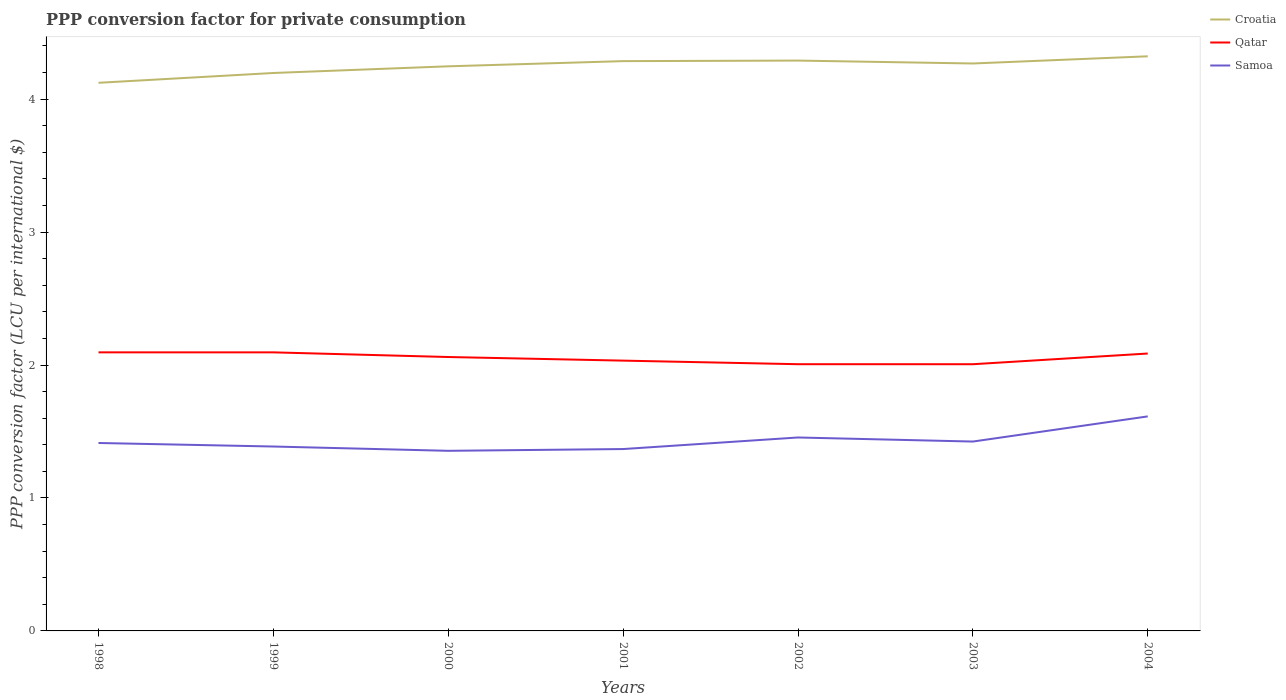Does the line corresponding to Qatar intersect with the line corresponding to Croatia?
Provide a short and direct response. No. Is the number of lines equal to the number of legend labels?
Ensure brevity in your answer.  Yes. Across all years, what is the maximum PPP conversion factor for private consumption in Qatar?
Make the answer very short. 2.01. What is the total PPP conversion factor for private consumption in Qatar in the graph?
Provide a short and direct response. 0.04. What is the difference between the highest and the second highest PPP conversion factor for private consumption in Croatia?
Offer a terse response. 0.2. What is the difference between the highest and the lowest PPP conversion factor for private consumption in Qatar?
Provide a succinct answer. 4. Are the values on the major ticks of Y-axis written in scientific E-notation?
Provide a short and direct response. No. Does the graph contain any zero values?
Make the answer very short. No. Does the graph contain grids?
Offer a very short reply. No. Where does the legend appear in the graph?
Make the answer very short. Top right. What is the title of the graph?
Offer a terse response. PPP conversion factor for private consumption. What is the label or title of the Y-axis?
Make the answer very short. PPP conversion factor (LCU per international $). What is the PPP conversion factor (LCU per international $) in Croatia in 1998?
Make the answer very short. 4.12. What is the PPP conversion factor (LCU per international $) of Qatar in 1998?
Make the answer very short. 2.1. What is the PPP conversion factor (LCU per international $) of Samoa in 1998?
Offer a terse response. 1.41. What is the PPP conversion factor (LCU per international $) in Croatia in 1999?
Make the answer very short. 4.2. What is the PPP conversion factor (LCU per international $) in Qatar in 1999?
Keep it short and to the point. 2.1. What is the PPP conversion factor (LCU per international $) in Samoa in 1999?
Make the answer very short. 1.39. What is the PPP conversion factor (LCU per international $) in Croatia in 2000?
Offer a terse response. 4.25. What is the PPP conversion factor (LCU per international $) in Qatar in 2000?
Ensure brevity in your answer.  2.06. What is the PPP conversion factor (LCU per international $) of Samoa in 2000?
Give a very brief answer. 1.35. What is the PPP conversion factor (LCU per international $) of Croatia in 2001?
Offer a very short reply. 4.29. What is the PPP conversion factor (LCU per international $) of Qatar in 2001?
Provide a short and direct response. 2.03. What is the PPP conversion factor (LCU per international $) of Samoa in 2001?
Make the answer very short. 1.37. What is the PPP conversion factor (LCU per international $) of Croatia in 2002?
Offer a terse response. 4.29. What is the PPP conversion factor (LCU per international $) in Qatar in 2002?
Offer a terse response. 2.01. What is the PPP conversion factor (LCU per international $) in Samoa in 2002?
Make the answer very short. 1.46. What is the PPP conversion factor (LCU per international $) of Croatia in 2003?
Provide a short and direct response. 4.27. What is the PPP conversion factor (LCU per international $) in Qatar in 2003?
Give a very brief answer. 2.01. What is the PPP conversion factor (LCU per international $) of Samoa in 2003?
Make the answer very short. 1.42. What is the PPP conversion factor (LCU per international $) in Croatia in 2004?
Your answer should be compact. 4.32. What is the PPP conversion factor (LCU per international $) of Qatar in 2004?
Provide a short and direct response. 2.09. What is the PPP conversion factor (LCU per international $) of Samoa in 2004?
Ensure brevity in your answer.  1.61. Across all years, what is the maximum PPP conversion factor (LCU per international $) in Croatia?
Offer a terse response. 4.32. Across all years, what is the maximum PPP conversion factor (LCU per international $) in Qatar?
Give a very brief answer. 2.1. Across all years, what is the maximum PPP conversion factor (LCU per international $) in Samoa?
Your answer should be compact. 1.61. Across all years, what is the minimum PPP conversion factor (LCU per international $) of Croatia?
Offer a terse response. 4.12. Across all years, what is the minimum PPP conversion factor (LCU per international $) of Qatar?
Your answer should be compact. 2.01. Across all years, what is the minimum PPP conversion factor (LCU per international $) of Samoa?
Offer a terse response. 1.35. What is the total PPP conversion factor (LCU per international $) of Croatia in the graph?
Your answer should be very brief. 29.73. What is the total PPP conversion factor (LCU per international $) of Qatar in the graph?
Offer a terse response. 14.38. What is the total PPP conversion factor (LCU per international $) of Samoa in the graph?
Make the answer very short. 10.02. What is the difference between the PPP conversion factor (LCU per international $) of Croatia in 1998 and that in 1999?
Keep it short and to the point. -0.07. What is the difference between the PPP conversion factor (LCU per international $) in Qatar in 1998 and that in 1999?
Make the answer very short. 0. What is the difference between the PPP conversion factor (LCU per international $) in Samoa in 1998 and that in 1999?
Your answer should be compact. 0.03. What is the difference between the PPP conversion factor (LCU per international $) in Croatia in 1998 and that in 2000?
Provide a short and direct response. -0.12. What is the difference between the PPP conversion factor (LCU per international $) in Qatar in 1998 and that in 2000?
Make the answer very short. 0.04. What is the difference between the PPP conversion factor (LCU per international $) in Samoa in 1998 and that in 2000?
Your response must be concise. 0.06. What is the difference between the PPP conversion factor (LCU per international $) of Croatia in 1998 and that in 2001?
Ensure brevity in your answer.  -0.16. What is the difference between the PPP conversion factor (LCU per international $) of Qatar in 1998 and that in 2001?
Your answer should be compact. 0.06. What is the difference between the PPP conversion factor (LCU per international $) in Samoa in 1998 and that in 2001?
Make the answer very short. 0.05. What is the difference between the PPP conversion factor (LCU per international $) of Croatia in 1998 and that in 2002?
Offer a very short reply. -0.17. What is the difference between the PPP conversion factor (LCU per international $) of Qatar in 1998 and that in 2002?
Keep it short and to the point. 0.09. What is the difference between the PPP conversion factor (LCU per international $) in Samoa in 1998 and that in 2002?
Offer a very short reply. -0.04. What is the difference between the PPP conversion factor (LCU per international $) in Croatia in 1998 and that in 2003?
Give a very brief answer. -0.15. What is the difference between the PPP conversion factor (LCU per international $) in Qatar in 1998 and that in 2003?
Ensure brevity in your answer.  0.09. What is the difference between the PPP conversion factor (LCU per international $) of Samoa in 1998 and that in 2003?
Keep it short and to the point. -0.01. What is the difference between the PPP conversion factor (LCU per international $) of Croatia in 1998 and that in 2004?
Your answer should be compact. -0.2. What is the difference between the PPP conversion factor (LCU per international $) of Qatar in 1998 and that in 2004?
Keep it short and to the point. 0.01. What is the difference between the PPP conversion factor (LCU per international $) in Samoa in 1998 and that in 2004?
Provide a succinct answer. -0.2. What is the difference between the PPP conversion factor (LCU per international $) of Croatia in 1999 and that in 2000?
Ensure brevity in your answer.  -0.05. What is the difference between the PPP conversion factor (LCU per international $) of Qatar in 1999 and that in 2000?
Your response must be concise. 0.04. What is the difference between the PPP conversion factor (LCU per international $) in Samoa in 1999 and that in 2000?
Make the answer very short. 0.03. What is the difference between the PPP conversion factor (LCU per international $) in Croatia in 1999 and that in 2001?
Your response must be concise. -0.09. What is the difference between the PPP conversion factor (LCU per international $) of Qatar in 1999 and that in 2001?
Provide a short and direct response. 0.06. What is the difference between the PPP conversion factor (LCU per international $) of Samoa in 1999 and that in 2001?
Offer a terse response. 0.02. What is the difference between the PPP conversion factor (LCU per international $) of Croatia in 1999 and that in 2002?
Make the answer very short. -0.09. What is the difference between the PPP conversion factor (LCU per international $) of Qatar in 1999 and that in 2002?
Ensure brevity in your answer.  0.09. What is the difference between the PPP conversion factor (LCU per international $) in Samoa in 1999 and that in 2002?
Offer a very short reply. -0.07. What is the difference between the PPP conversion factor (LCU per international $) of Croatia in 1999 and that in 2003?
Your response must be concise. -0.07. What is the difference between the PPP conversion factor (LCU per international $) in Qatar in 1999 and that in 2003?
Your answer should be compact. 0.09. What is the difference between the PPP conversion factor (LCU per international $) of Samoa in 1999 and that in 2003?
Ensure brevity in your answer.  -0.04. What is the difference between the PPP conversion factor (LCU per international $) in Croatia in 1999 and that in 2004?
Make the answer very short. -0.13. What is the difference between the PPP conversion factor (LCU per international $) in Qatar in 1999 and that in 2004?
Make the answer very short. 0.01. What is the difference between the PPP conversion factor (LCU per international $) in Samoa in 1999 and that in 2004?
Offer a very short reply. -0.23. What is the difference between the PPP conversion factor (LCU per international $) in Croatia in 2000 and that in 2001?
Make the answer very short. -0.04. What is the difference between the PPP conversion factor (LCU per international $) in Qatar in 2000 and that in 2001?
Your answer should be compact. 0.03. What is the difference between the PPP conversion factor (LCU per international $) in Samoa in 2000 and that in 2001?
Your answer should be compact. -0.01. What is the difference between the PPP conversion factor (LCU per international $) in Croatia in 2000 and that in 2002?
Provide a short and direct response. -0.04. What is the difference between the PPP conversion factor (LCU per international $) of Qatar in 2000 and that in 2002?
Offer a terse response. 0.05. What is the difference between the PPP conversion factor (LCU per international $) in Samoa in 2000 and that in 2002?
Give a very brief answer. -0.1. What is the difference between the PPP conversion factor (LCU per international $) in Croatia in 2000 and that in 2003?
Provide a short and direct response. -0.02. What is the difference between the PPP conversion factor (LCU per international $) of Qatar in 2000 and that in 2003?
Offer a terse response. 0.05. What is the difference between the PPP conversion factor (LCU per international $) in Samoa in 2000 and that in 2003?
Offer a terse response. -0.07. What is the difference between the PPP conversion factor (LCU per international $) of Croatia in 2000 and that in 2004?
Give a very brief answer. -0.08. What is the difference between the PPP conversion factor (LCU per international $) in Qatar in 2000 and that in 2004?
Offer a terse response. -0.03. What is the difference between the PPP conversion factor (LCU per international $) in Samoa in 2000 and that in 2004?
Give a very brief answer. -0.26. What is the difference between the PPP conversion factor (LCU per international $) of Croatia in 2001 and that in 2002?
Your response must be concise. -0. What is the difference between the PPP conversion factor (LCU per international $) of Qatar in 2001 and that in 2002?
Keep it short and to the point. 0.03. What is the difference between the PPP conversion factor (LCU per international $) of Samoa in 2001 and that in 2002?
Your response must be concise. -0.09. What is the difference between the PPP conversion factor (LCU per international $) in Croatia in 2001 and that in 2003?
Offer a terse response. 0.02. What is the difference between the PPP conversion factor (LCU per international $) of Qatar in 2001 and that in 2003?
Ensure brevity in your answer.  0.03. What is the difference between the PPP conversion factor (LCU per international $) in Samoa in 2001 and that in 2003?
Your response must be concise. -0.06. What is the difference between the PPP conversion factor (LCU per international $) in Croatia in 2001 and that in 2004?
Ensure brevity in your answer.  -0.04. What is the difference between the PPP conversion factor (LCU per international $) of Qatar in 2001 and that in 2004?
Keep it short and to the point. -0.05. What is the difference between the PPP conversion factor (LCU per international $) in Samoa in 2001 and that in 2004?
Your response must be concise. -0.25. What is the difference between the PPP conversion factor (LCU per international $) of Croatia in 2002 and that in 2003?
Make the answer very short. 0.02. What is the difference between the PPP conversion factor (LCU per international $) in Samoa in 2002 and that in 2003?
Offer a very short reply. 0.03. What is the difference between the PPP conversion factor (LCU per international $) in Croatia in 2002 and that in 2004?
Keep it short and to the point. -0.03. What is the difference between the PPP conversion factor (LCU per international $) of Qatar in 2002 and that in 2004?
Offer a very short reply. -0.08. What is the difference between the PPP conversion factor (LCU per international $) in Samoa in 2002 and that in 2004?
Ensure brevity in your answer.  -0.16. What is the difference between the PPP conversion factor (LCU per international $) in Croatia in 2003 and that in 2004?
Provide a succinct answer. -0.05. What is the difference between the PPP conversion factor (LCU per international $) in Qatar in 2003 and that in 2004?
Provide a short and direct response. -0.08. What is the difference between the PPP conversion factor (LCU per international $) of Samoa in 2003 and that in 2004?
Offer a terse response. -0.19. What is the difference between the PPP conversion factor (LCU per international $) of Croatia in 1998 and the PPP conversion factor (LCU per international $) of Qatar in 1999?
Your answer should be compact. 2.03. What is the difference between the PPP conversion factor (LCU per international $) of Croatia in 1998 and the PPP conversion factor (LCU per international $) of Samoa in 1999?
Offer a terse response. 2.74. What is the difference between the PPP conversion factor (LCU per international $) in Qatar in 1998 and the PPP conversion factor (LCU per international $) in Samoa in 1999?
Offer a terse response. 0.71. What is the difference between the PPP conversion factor (LCU per international $) in Croatia in 1998 and the PPP conversion factor (LCU per international $) in Qatar in 2000?
Offer a very short reply. 2.06. What is the difference between the PPP conversion factor (LCU per international $) of Croatia in 1998 and the PPP conversion factor (LCU per international $) of Samoa in 2000?
Your response must be concise. 2.77. What is the difference between the PPP conversion factor (LCU per international $) of Qatar in 1998 and the PPP conversion factor (LCU per international $) of Samoa in 2000?
Provide a short and direct response. 0.74. What is the difference between the PPP conversion factor (LCU per international $) of Croatia in 1998 and the PPP conversion factor (LCU per international $) of Qatar in 2001?
Provide a succinct answer. 2.09. What is the difference between the PPP conversion factor (LCU per international $) in Croatia in 1998 and the PPP conversion factor (LCU per international $) in Samoa in 2001?
Provide a succinct answer. 2.75. What is the difference between the PPP conversion factor (LCU per international $) in Qatar in 1998 and the PPP conversion factor (LCU per international $) in Samoa in 2001?
Your response must be concise. 0.73. What is the difference between the PPP conversion factor (LCU per international $) of Croatia in 1998 and the PPP conversion factor (LCU per international $) of Qatar in 2002?
Give a very brief answer. 2.12. What is the difference between the PPP conversion factor (LCU per international $) in Croatia in 1998 and the PPP conversion factor (LCU per international $) in Samoa in 2002?
Give a very brief answer. 2.67. What is the difference between the PPP conversion factor (LCU per international $) of Qatar in 1998 and the PPP conversion factor (LCU per international $) of Samoa in 2002?
Offer a terse response. 0.64. What is the difference between the PPP conversion factor (LCU per international $) of Croatia in 1998 and the PPP conversion factor (LCU per international $) of Qatar in 2003?
Make the answer very short. 2.12. What is the difference between the PPP conversion factor (LCU per international $) in Croatia in 1998 and the PPP conversion factor (LCU per international $) in Samoa in 2003?
Offer a very short reply. 2.7. What is the difference between the PPP conversion factor (LCU per international $) of Qatar in 1998 and the PPP conversion factor (LCU per international $) of Samoa in 2003?
Provide a succinct answer. 0.67. What is the difference between the PPP conversion factor (LCU per international $) in Croatia in 1998 and the PPP conversion factor (LCU per international $) in Qatar in 2004?
Your answer should be very brief. 2.04. What is the difference between the PPP conversion factor (LCU per international $) of Croatia in 1998 and the PPP conversion factor (LCU per international $) of Samoa in 2004?
Provide a short and direct response. 2.51. What is the difference between the PPP conversion factor (LCU per international $) of Qatar in 1998 and the PPP conversion factor (LCU per international $) of Samoa in 2004?
Your response must be concise. 0.48. What is the difference between the PPP conversion factor (LCU per international $) of Croatia in 1999 and the PPP conversion factor (LCU per international $) of Qatar in 2000?
Ensure brevity in your answer.  2.14. What is the difference between the PPP conversion factor (LCU per international $) of Croatia in 1999 and the PPP conversion factor (LCU per international $) of Samoa in 2000?
Provide a succinct answer. 2.84. What is the difference between the PPP conversion factor (LCU per international $) in Qatar in 1999 and the PPP conversion factor (LCU per international $) in Samoa in 2000?
Your answer should be very brief. 0.74. What is the difference between the PPP conversion factor (LCU per international $) in Croatia in 1999 and the PPP conversion factor (LCU per international $) in Qatar in 2001?
Your answer should be very brief. 2.16. What is the difference between the PPP conversion factor (LCU per international $) in Croatia in 1999 and the PPP conversion factor (LCU per international $) in Samoa in 2001?
Give a very brief answer. 2.83. What is the difference between the PPP conversion factor (LCU per international $) in Qatar in 1999 and the PPP conversion factor (LCU per international $) in Samoa in 2001?
Keep it short and to the point. 0.73. What is the difference between the PPP conversion factor (LCU per international $) in Croatia in 1999 and the PPP conversion factor (LCU per international $) in Qatar in 2002?
Keep it short and to the point. 2.19. What is the difference between the PPP conversion factor (LCU per international $) in Croatia in 1999 and the PPP conversion factor (LCU per international $) in Samoa in 2002?
Keep it short and to the point. 2.74. What is the difference between the PPP conversion factor (LCU per international $) of Qatar in 1999 and the PPP conversion factor (LCU per international $) of Samoa in 2002?
Your answer should be compact. 0.64. What is the difference between the PPP conversion factor (LCU per international $) in Croatia in 1999 and the PPP conversion factor (LCU per international $) in Qatar in 2003?
Ensure brevity in your answer.  2.19. What is the difference between the PPP conversion factor (LCU per international $) in Croatia in 1999 and the PPP conversion factor (LCU per international $) in Samoa in 2003?
Make the answer very short. 2.77. What is the difference between the PPP conversion factor (LCU per international $) of Qatar in 1999 and the PPP conversion factor (LCU per international $) of Samoa in 2003?
Provide a short and direct response. 0.67. What is the difference between the PPP conversion factor (LCU per international $) in Croatia in 1999 and the PPP conversion factor (LCU per international $) in Qatar in 2004?
Offer a terse response. 2.11. What is the difference between the PPP conversion factor (LCU per international $) in Croatia in 1999 and the PPP conversion factor (LCU per international $) in Samoa in 2004?
Give a very brief answer. 2.58. What is the difference between the PPP conversion factor (LCU per international $) of Qatar in 1999 and the PPP conversion factor (LCU per international $) of Samoa in 2004?
Keep it short and to the point. 0.48. What is the difference between the PPP conversion factor (LCU per international $) of Croatia in 2000 and the PPP conversion factor (LCU per international $) of Qatar in 2001?
Make the answer very short. 2.21. What is the difference between the PPP conversion factor (LCU per international $) of Croatia in 2000 and the PPP conversion factor (LCU per international $) of Samoa in 2001?
Provide a succinct answer. 2.88. What is the difference between the PPP conversion factor (LCU per international $) in Qatar in 2000 and the PPP conversion factor (LCU per international $) in Samoa in 2001?
Provide a succinct answer. 0.69. What is the difference between the PPP conversion factor (LCU per international $) of Croatia in 2000 and the PPP conversion factor (LCU per international $) of Qatar in 2002?
Keep it short and to the point. 2.24. What is the difference between the PPP conversion factor (LCU per international $) in Croatia in 2000 and the PPP conversion factor (LCU per international $) in Samoa in 2002?
Keep it short and to the point. 2.79. What is the difference between the PPP conversion factor (LCU per international $) of Qatar in 2000 and the PPP conversion factor (LCU per international $) of Samoa in 2002?
Keep it short and to the point. 0.61. What is the difference between the PPP conversion factor (LCU per international $) of Croatia in 2000 and the PPP conversion factor (LCU per international $) of Qatar in 2003?
Provide a succinct answer. 2.24. What is the difference between the PPP conversion factor (LCU per international $) of Croatia in 2000 and the PPP conversion factor (LCU per international $) of Samoa in 2003?
Keep it short and to the point. 2.82. What is the difference between the PPP conversion factor (LCU per international $) of Qatar in 2000 and the PPP conversion factor (LCU per international $) of Samoa in 2003?
Your response must be concise. 0.64. What is the difference between the PPP conversion factor (LCU per international $) of Croatia in 2000 and the PPP conversion factor (LCU per international $) of Qatar in 2004?
Provide a succinct answer. 2.16. What is the difference between the PPP conversion factor (LCU per international $) of Croatia in 2000 and the PPP conversion factor (LCU per international $) of Samoa in 2004?
Make the answer very short. 2.63. What is the difference between the PPP conversion factor (LCU per international $) of Qatar in 2000 and the PPP conversion factor (LCU per international $) of Samoa in 2004?
Offer a very short reply. 0.45. What is the difference between the PPP conversion factor (LCU per international $) in Croatia in 2001 and the PPP conversion factor (LCU per international $) in Qatar in 2002?
Provide a short and direct response. 2.28. What is the difference between the PPP conversion factor (LCU per international $) of Croatia in 2001 and the PPP conversion factor (LCU per international $) of Samoa in 2002?
Your answer should be compact. 2.83. What is the difference between the PPP conversion factor (LCU per international $) of Qatar in 2001 and the PPP conversion factor (LCU per international $) of Samoa in 2002?
Make the answer very short. 0.58. What is the difference between the PPP conversion factor (LCU per international $) in Croatia in 2001 and the PPP conversion factor (LCU per international $) in Qatar in 2003?
Provide a short and direct response. 2.28. What is the difference between the PPP conversion factor (LCU per international $) of Croatia in 2001 and the PPP conversion factor (LCU per international $) of Samoa in 2003?
Give a very brief answer. 2.86. What is the difference between the PPP conversion factor (LCU per international $) in Qatar in 2001 and the PPP conversion factor (LCU per international $) in Samoa in 2003?
Your response must be concise. 0.61. What is the difference between the PPP conversion factor (LCU per international $) in Croatia in 2001 and the PPP conversion factor (LCU per international $) in Qatar in 2004?
Provide a short and direct response. 2.2. What is the difference between the PPP conversion factor (LCU per international $) in Croatia in 2001 and the PPP conversion factor (LCU per international $) in Samoa in 2004?
Give a very brief answer. 2.67. What is the difference between the PPP conversion factor (LCU per international $) in Qatar in 2001 and the PPP conversion factor (LCU per international $) in Samoa in 2004?
Provide a succinct answer. 0.42. What is the difference between the PPP conversion factor (LCU per international $) in Croatia in 2002 and the PPP conversion factor (LCU per international $) in Qatar in 2003?
Make the answer very short. 2.28. What is the difference between the PPP conversion factor (LCU per international $) of Croatia in 2002 and the PPP conversion factor (LCU per international $) of Samoa in 2003?
Offer a very short reply. 2.87. What is the difference between the PPP conversion factor (LCU per international $) of Qatar in 2002 and the PPP conversion factor (LCU per international $) of Samoa in 2003?
Make the answer very short. 0.58. What is the difference between the PPP conversion factor (LCU per international $) in Croatia in 2002 and the PPP conversion factor (LCU per international $) in Qatar in 2004?
Your answer should be compact. 2.2. What is the difference between the PPP conversion factor (LCU per international $) of Croatia in 2002 and the PPP conversion factor (LCU per international $) of Samoa in 2004?
Make the answer very short. 2.68. What is the difference between the PPP conversion factor (LCU per international $) of Qatar in 2002 and the PPP conversion factor (LCU per international $) of Samoa in 2004?
Provide a succinct answer. 0.39. What is the difference between the PPP conversion factor (LCU per international $) of Croatia in 2003 and the PPP conversion factor (LCU per international $) of Qatar in 2004?
Your answer should be compact. 2.18. What is the difference between the PPP conversion factor (LCU per international $) of Croatia in 2003 and the PPP conversion factor (LCU per international $) of Samoa in 2004?
Your response must be concise. 2.65. What is the difference between the PPP conversion factor (LCU per international $) of Qatar in 2003 and the PPP conversion factor (LCU per international $) of Samoa in 2004?
Provide a succinct answer. 0.39. What is the average PPP conversion factor (LCU per international $) in Croatia per year?
Provide a succinct answer. 4.25. What is the average PPP conversion factor (LCU per international $) in Qatar per year?
Ensure brevity in your answer.  2.05. What is the average PPP conversion factor (LCU per international $) in Samoa per year?
Provide a short and direct response. 1.43. In the year 1998, what is the difference between the PPP conversion factor (LCU per international $) in Croatia and PPP conversion factor (LCU per international $) in Qatar?
Your response must be concise. 2.03. In the year 1998, what is the difference between the PPP conversion factor (LCU per international $) of Croatia and PPP conversion factor (LCU per international $) of Samoa?
Ensure brevity in your answer.  2.71. In the year 1998, what is the difference between the PPP conversion factor (LCU per international $) of Qatar and PPP conversion factor (LCU per international $) of Samoa?
Ensure brevity in your answer.  0.68. In the year 1999, what is the difference between the PPP conversion factor (LCU per international $) of Croatia and PPP conversion factor (LCU per international $) of Qatar?
Your answer should be very brief. 2.1. In the year 1999, what is the difference between the PPP conversion factor (LCU per international $) in Croatia and PPP conversion factor (LCU per international $) in Samoa?
Provide a succinct answer. 2.81. In the year 1999, what is the difference between the PPP conversion factor (LCU per international $) of Qatar and PPP conversion factor (LCU per international $) of Samoa?
Offer a very short reply. 0.71. In the year 2000, what is the difference between the PPP conversion factor (LCU per international $) of Croatia and PPP conversion factor (LCU per international $) of Qatar?
Keep it short and to the point. 2.19. In the year 2000, what is the difference between the PPP conversion factor (LCU per international $) of Croatia and PPP conversion factor (LCU per international $) of Samoa?
Your response must be concise. 2.89. In the year 2000, what is the difference between the PPP conversion factor (LCU per international $) in Qatar and PPP conversion factor (LCU per international $) in Samoa?
Your response must be concise. 0.71. In the year 2001, what is the difference between the PPP conversion factor (LCU per international $) of Croatia and PPP conversion factor (LCU per international $) of Qatar?
Your answer should be very brief. 2.25. In the year 2001, what is the difference between the PPP conversion factor (LCU per international $) in Croatia and PPP conversion factor (LCU per international $) in Samoa?
Your response must be concise. 2.92. In the year 2001, what is the difference between the PPP conversion factor (LCU per international $) of Qatar and PPP conversion factor (LCU per international $) of Samoa?
Your response must be concise. 0.67. In the year 2002, what is the difference between the PPP conversion factor (LCU per international $) of Croatia and PPP conversion factor (LCU per international $) of Qatar?
Your answer should be very brief. 2.28. In the year 2002, what is the difference between the PPP conversion factor (LCU per international $) of Croatia and PPP conversion factor (LCU per international $) of Samoa?
Your answer should be compact. 2.84. In the year 2002, what is the difference between the PPP conversion factor (LCU per international $) of Qatar and PPP conversion factor (LCU per international $) of Samoa?
Make the answer very short. 0.55. In the year 2003, what is the difference between the PPP conversion factor (LCU per international $) of Croatia and PPP conversion factor (LCU per international $) of Qatar?
Give a very brief answer. 2.26. In the year 2003, what is the difference between the PPP conversion factor (LCU per international $) of Croatia and PPP conversion factor (LCU per international $) of Samoa?
Provide a short and direct response. 2.84. In the year 2003, what is the difference between the PPP conversion factor (LCU per international $) of Qatar and PPP conversion factor (LCU per international $) of Samoa?
Offer a very short reply. 0.58. In the year 2004, what is the difference between the PPP conversion factor (LCU per international $) in Croatia and PPP conversion factor (LCU per international $) in Qatar?
Offer a very short reply. 2.24. In the year 2004, what is the difference between the PPP conversion factor (LCU per international $) of Croatia and PPP conversion factor (LCU per international $) of Samoa?
Your answer should be compact. 2.71. In the year 2004, what is the difference between the PPP conversion factor (LCU per international $) in Qatar and PPP conversion factor (LCU per international $) in Samoa?
Ensure brevity in your answer.  0.47. What is the ratio of the PPP conversion factor (LCU per international $) of Croatia in 1998 to that in 1999?
Keep it short and to the point. 0.98. What is the ratio of the PPP conversion factor (LCU per international $) of Samoa in 1998 to that in 1999?
Your answer should be compact. 1.02. What is the ratio of the PPP conversion factor (LCU per international $) of Croatia in 1998 to that in 2000?
Offer a terse response. 0.97. What is the ratio of the PPP conversion factor (LCU per international $) in Samoa in 1998 to that in 2000?
Ensure brevity in your answer.  1.04. What is the ratio of the PPP conversion factor (LCU per international $) of Croatia in 1998 to that in 2001?
Offer a terse response. 0.96. What is the ratio of the PPP conversion factor (LCU per international $) in Qatar in 1998 to that in 2001?
Give a very brief answer. 1.03. What is the ratio of the PPP conversion factor (LCU per international $) of Samoa in 1998 to that in 2001?
Your answer should be very brief. 1.03. What is the ratio of the PPP conversion factor (LCU per international $) of Croatia in 1998 to that in 2002?
Your answer should be compact. 0.96. What is the ratio of the PPP conversion factor (LCU per international $) in Qatar in 1998 to that in 2002?
Give a very brief answer. 1.04. What is the ratio of the PPP conversion factor (LCU per international $) in Samoa in 1998 to that in 2002?
Your response must be concise. 0.97. What is the ratio of the PPP conversion factor (LCU per international $) in Croatia in 1998 to that in 2003?
Provide a succinct answer. 0.97. What is the ratio of the PPP conversion factor (LCU per international $) of Qatar in 1998 to that in 2003?
Your answer should be very brief. 1.04. What is the ratio of the PPP conversion factor (LCU per international $) of Croatia in 1998 to that in 2004?
Offer a very short reply. 0.95. What is the ratio of the PPP conversion factor (LCU per international $) of Qatar in 1998 to that in 2004?
Offer a very short reply. 1. What is the ratio of the PPP conversion factor (LCU per international $) of Samoa in 1998 to that in 2004?
Ensure brevity in your answer.  0.88. What is the ratio of the PPP conversion factor (LCU per international $) of Croatia in 1999 to that in 2000?
Keep it short and to the point. 0.99. What is the ratio of the PPP conversion factor (LCU per international $) in Qatar in 1999 to that in 2000?
Provide a succinct answer. 1.02. What is the ratio of the PPP conversion factor (LCU per international $) of Samoa in 1999 to that in 2000?
Provide a succinct answer. 1.02. What is the ratio of the PPP conversion factor (LCU per international $) of Croatia in 1999 to that in 2001?
Offer a terse response. 0.98. What is the ratio of the PPP conversion factor (LCU per international $) in Qatar in 1999 to that in 2001?
Provide a succinct answer. 1.03. What is the ratio of the PPP conversion factor (LCU per international $) of Samoa in 1999 to that in 2001?
Give a very brief answer. 1.01. What is the ratio of the PPP conversion factor (LCU per international $) of Croatia in 1999 to that in 2002?
Give a very brief answer. 0.98. What is the ratio of the PPP conversion factor (LCU per international $) of Qatar in 1999 to that in 2002?
Offer a terse response. 1.04. What is the ratio of the PPP conversion factor (LCU per international $) of Samoa in 1999 to that in 2002?
Keep it short and to the point. 0.95. What is the ratio of the PPP conversion factor (LCU per international $) of Croatia in 1999 to that in 2003?
Offer a terse response. 0.98. What is the ratio of the PPP conversion factor (LCU per international $) in Qatar in 1999 to that in 2003?
Offer a very short reply. 1.04. What is the ratio of the PPP conversion factor (LCU per international $) of Samoa in 1999 to that in 2003?
Your answer should be compact. 0.97. What is the ratio of the PPP conversion factor (LCU per international $) in Qatar in 1999 to that in 2004?
Provide a succinct answer. 1. What is the ratio of the PPP conversion factor (LCU per international $) of Samoa in 1999 to that in 2004?
Make the answer very short. 0.86. What is the ratio of the PPP conversion factor (LCU per international $) of Croatia in 2000 to that in 2001?
Ensure brevity in your answer.  0.99. What is the ratio of the PPP conversion factor (LCU per international $) of Qatar in 2000 to that in 2001?
Keep it short and to the point. 1.01. What is the ratio of the PPP conversion factor (LCU per international $) in Samoa in 2000 to that in 2001?
Your answer should be compact. 0.99. What is the ratio of the PPP conversion factor (LCU per international $) of Croatia in 2000 to that in 2002?
Your answer should be compact. 0.99. What is the ratio of the PPP conversion factor (LCU per international $) of Qatar in 2000 to that in 2003?
Give a very brief answer. 1.03. What is the ratio of the PPP conversion factor (LCU per international $) of Samoa in 2000 to that in 2003?
Ensure brevity in your answer.  0.95. What is the ratio of the PPP conversion factor (LCU per international $) in Croatia in 2000 to that in 2004?
Your answer should be very brief. 0.98. What is the ratio of the PPP conversion factor (LCU per international $) in Qatar in 2000 to that in 2004?
Offer a terse response. 0.99. What is the ratio of the PPP conversion factor (LCU per international $) of Samoa in 2000 to that in 2004?
Offer a very short reply. 0.84. What is the ratio of the PPP conversion factor (LCU per international $) of Qatar in 2001 to that in 2002?
Give a very brief answer. 1.01. What is the ratio of the PPP conversion factor (LCU per international $) of Samoa in 2001 to that in 2002?
Provide a succinct answer. 0.94. What is the ratio of the PPP conversion factor (LCU per international $) in Qatar in 2001 to that in 2003?
Offer a very short reply. 1.01. What is the ratio of the PPP conversion factor (LCU per international $) of Samoa in 2001 to that in 2003?
Keep it short and to the point. 0.96. What is the ratio of the PPP conversion factor (LCU per international $) of Croatia in 2001 to that in 2004?
Make the answer very short. 0.99. What is the ratio of the PPP conversion factor (LCU per international $) of Qatar in 2001 to that in 2004?
Keep it short and to the point. 0.97. What is the ratio of the PPP conversion factor (LCU per international $) of Samoa in 2001 to that in 2004?
Your answer should be very brief. 0.85. What is the ratio of the PPP conversion factor (LCU per international $) of Croatia in 2002 to that in 2003?
Your answer should be very brief. 1.01. What is the ratio of the PPP conversion factor (LCU per international $) in Qatar in 2002 to that in 2003?
Provide a succinct answer. 1. What is the ratio of the PPP conversion factor (LCU per international $) in Samoa in 2002 to that in 2003?
Give a very brief answer. 1.02. What is the ratio of the PPP conversion factor (LCU per international $) in Croatia in 2002 to that in 2004?
Give a very brief answer. 0.99. What is the ratio of the PPP conversion factor (LCU per international $) in Qatar in 2002 to that in 2004?
Give a very brief answer. 0.96. What is the ratio of the PPP conversion factor (LCU per international $) of Samoa in 2002 to that in 2004?
Ensure brevity in your answer.  0.9. What is the ratio of the PPP conversion factor (LCU per international $) of Croatia in 2003 to that in 2004?
Offer a very short reply. 0.99. What is the ratio of the PPP conversion factor (LCU per international $) in Qatar in 2003 to that in 2004?
Provide a succinct answer. 0.96. What is the ratio of the PPP conversion factor (LCU per international $) of Samoa in 2003 to that in 2004?
Provide a short and direct response. 0.88. What is the difference between the highest and the second highest PPP conversion factor (LCU per international $) in Croatia?
Give a very brief answer. 0.03. What is the difference between the highest and the second highest PPP conversion factor (LCU per international $) of Qatar?
Provide a succinct answer. 0. What is the difference between the highest and the second highest PPP conversion factor (LCU per international $) of Samoa?
Offer a very short reply. 0.16. What is the difference between the highest and the lowest PPP conversion factor (LCU per international $) in Croatia?
Provide a short and direct response. 0.2. What is the difference between the highest and the lowest PPP conversion factor (LCU per international $) in Qatar?
Offer a very short reply. 0.09. What is the difference between the highest and the lowest PPP conversion factor (LCU per international $) of Samoa?
Offer a very short reply. 0.26. 